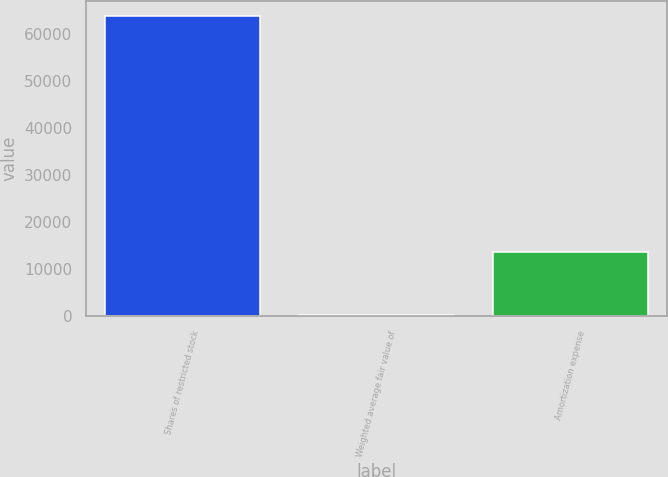<chart> <loc_0><loc_0><loc_500><loc_500><bar_chart><fcel>Shares of restricted stock<fcel>Weighted average fair value of<fcel>Amortization expense<nl><fcel>63738<fcel>197.17<fcel>13692<nl></chart> 